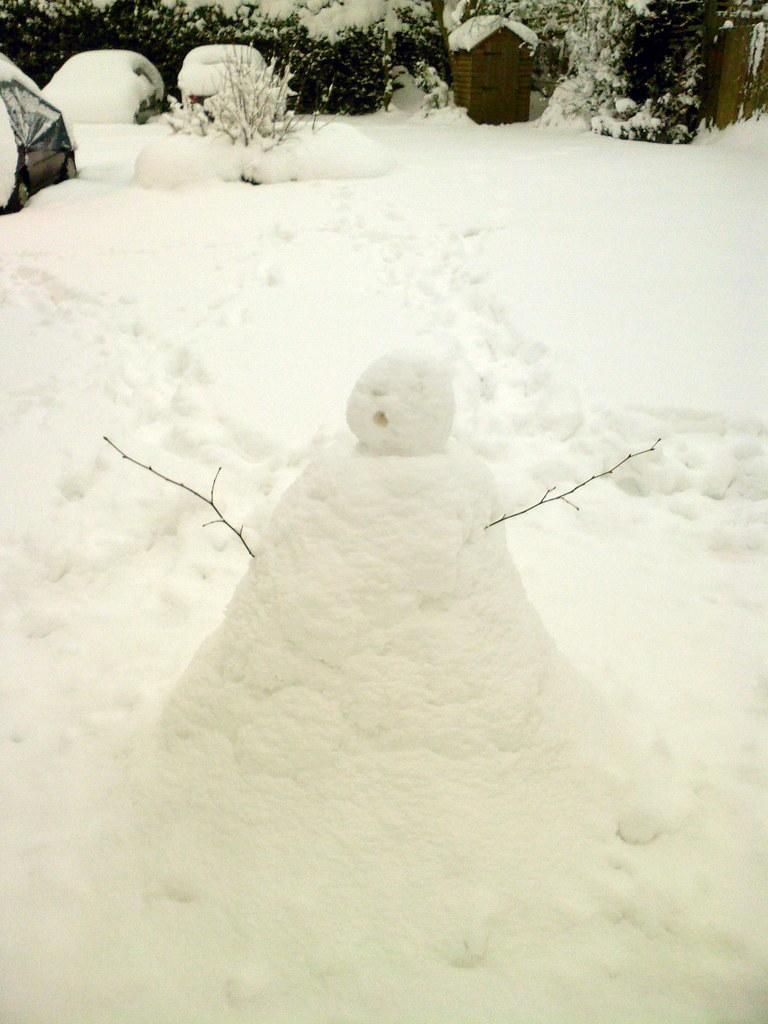What is the main feature of the image? The main feature of the image is snow. What else can be seen in the image besides snow? There are trees in the image. How are the trees affected by the snow? The trees are covered with snow. Where are the trees located in the image? The trees are located at the top side of the image. What type of copper object can be seen in the image? There is no copper object present in the image. Can you tell me the word your sister said while looking at the image? The provided facts do not mention a sister or any spoken words, so we cannot answer this question. 